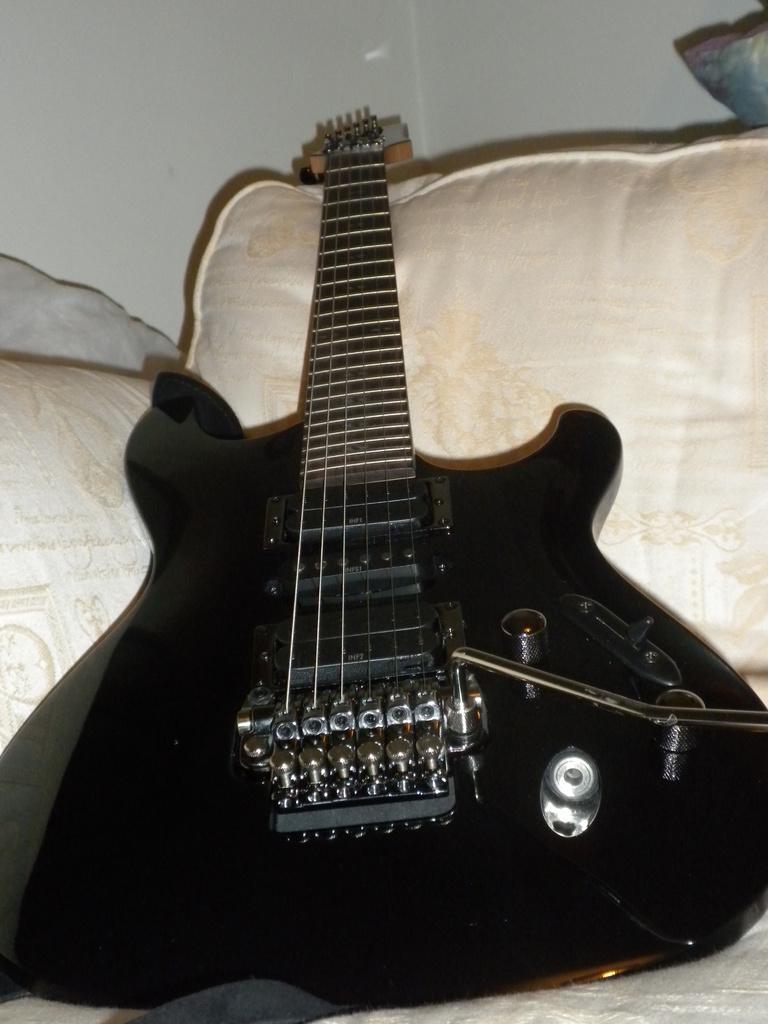Describe this image in one or two sentences. In this image, we can see guitar and pillows on the bed. 